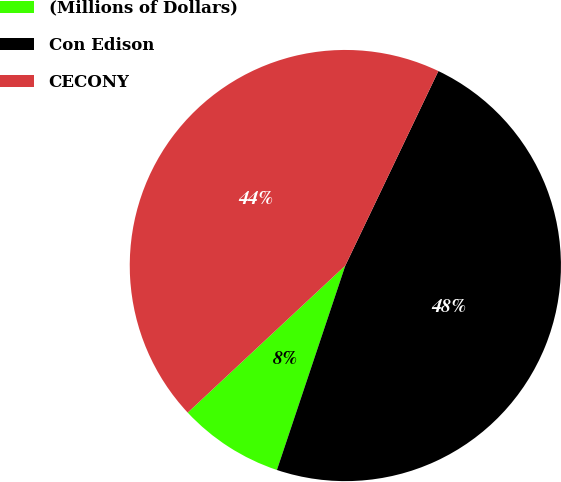Convert chart to OTSL. <chart><loc_0><loc_0><loc_500><loc_500><pie_chart><fcel>(Millions of Dollars)<fcel>Con Edison<fcel>CECONY<nl><fcel>7.91%<fcel>48.04%<fcel>44.05%<nl></chart> 